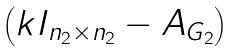<formula> <loc_0><loc_0><loc_500><loc_500>\begin{pmatrix} k I _ { n _ { 2 } \times n _ { 2 } } - A _ { G _ { 2 } } \end{pmatrix}</formula> 